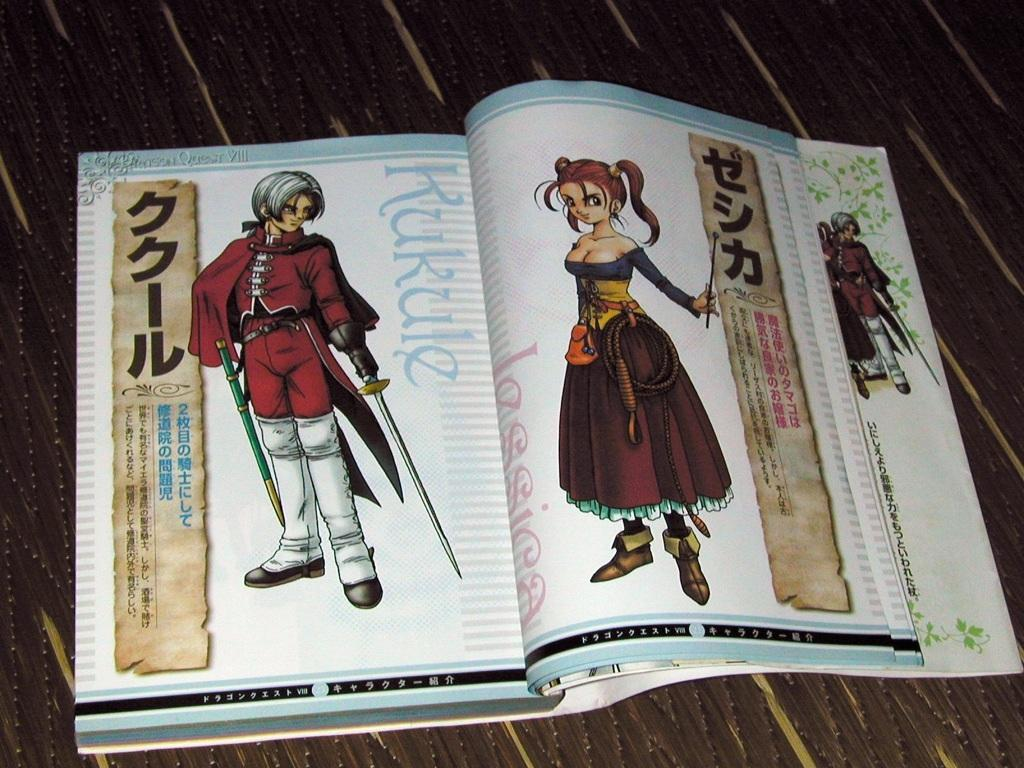Provide a one-sentence caption for the provided image. A japanese book with a character named Kukule. 